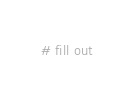<code> <loc_0><loc_0><loc_500><loc_500><_Dockerfile_># fill out
</code> 